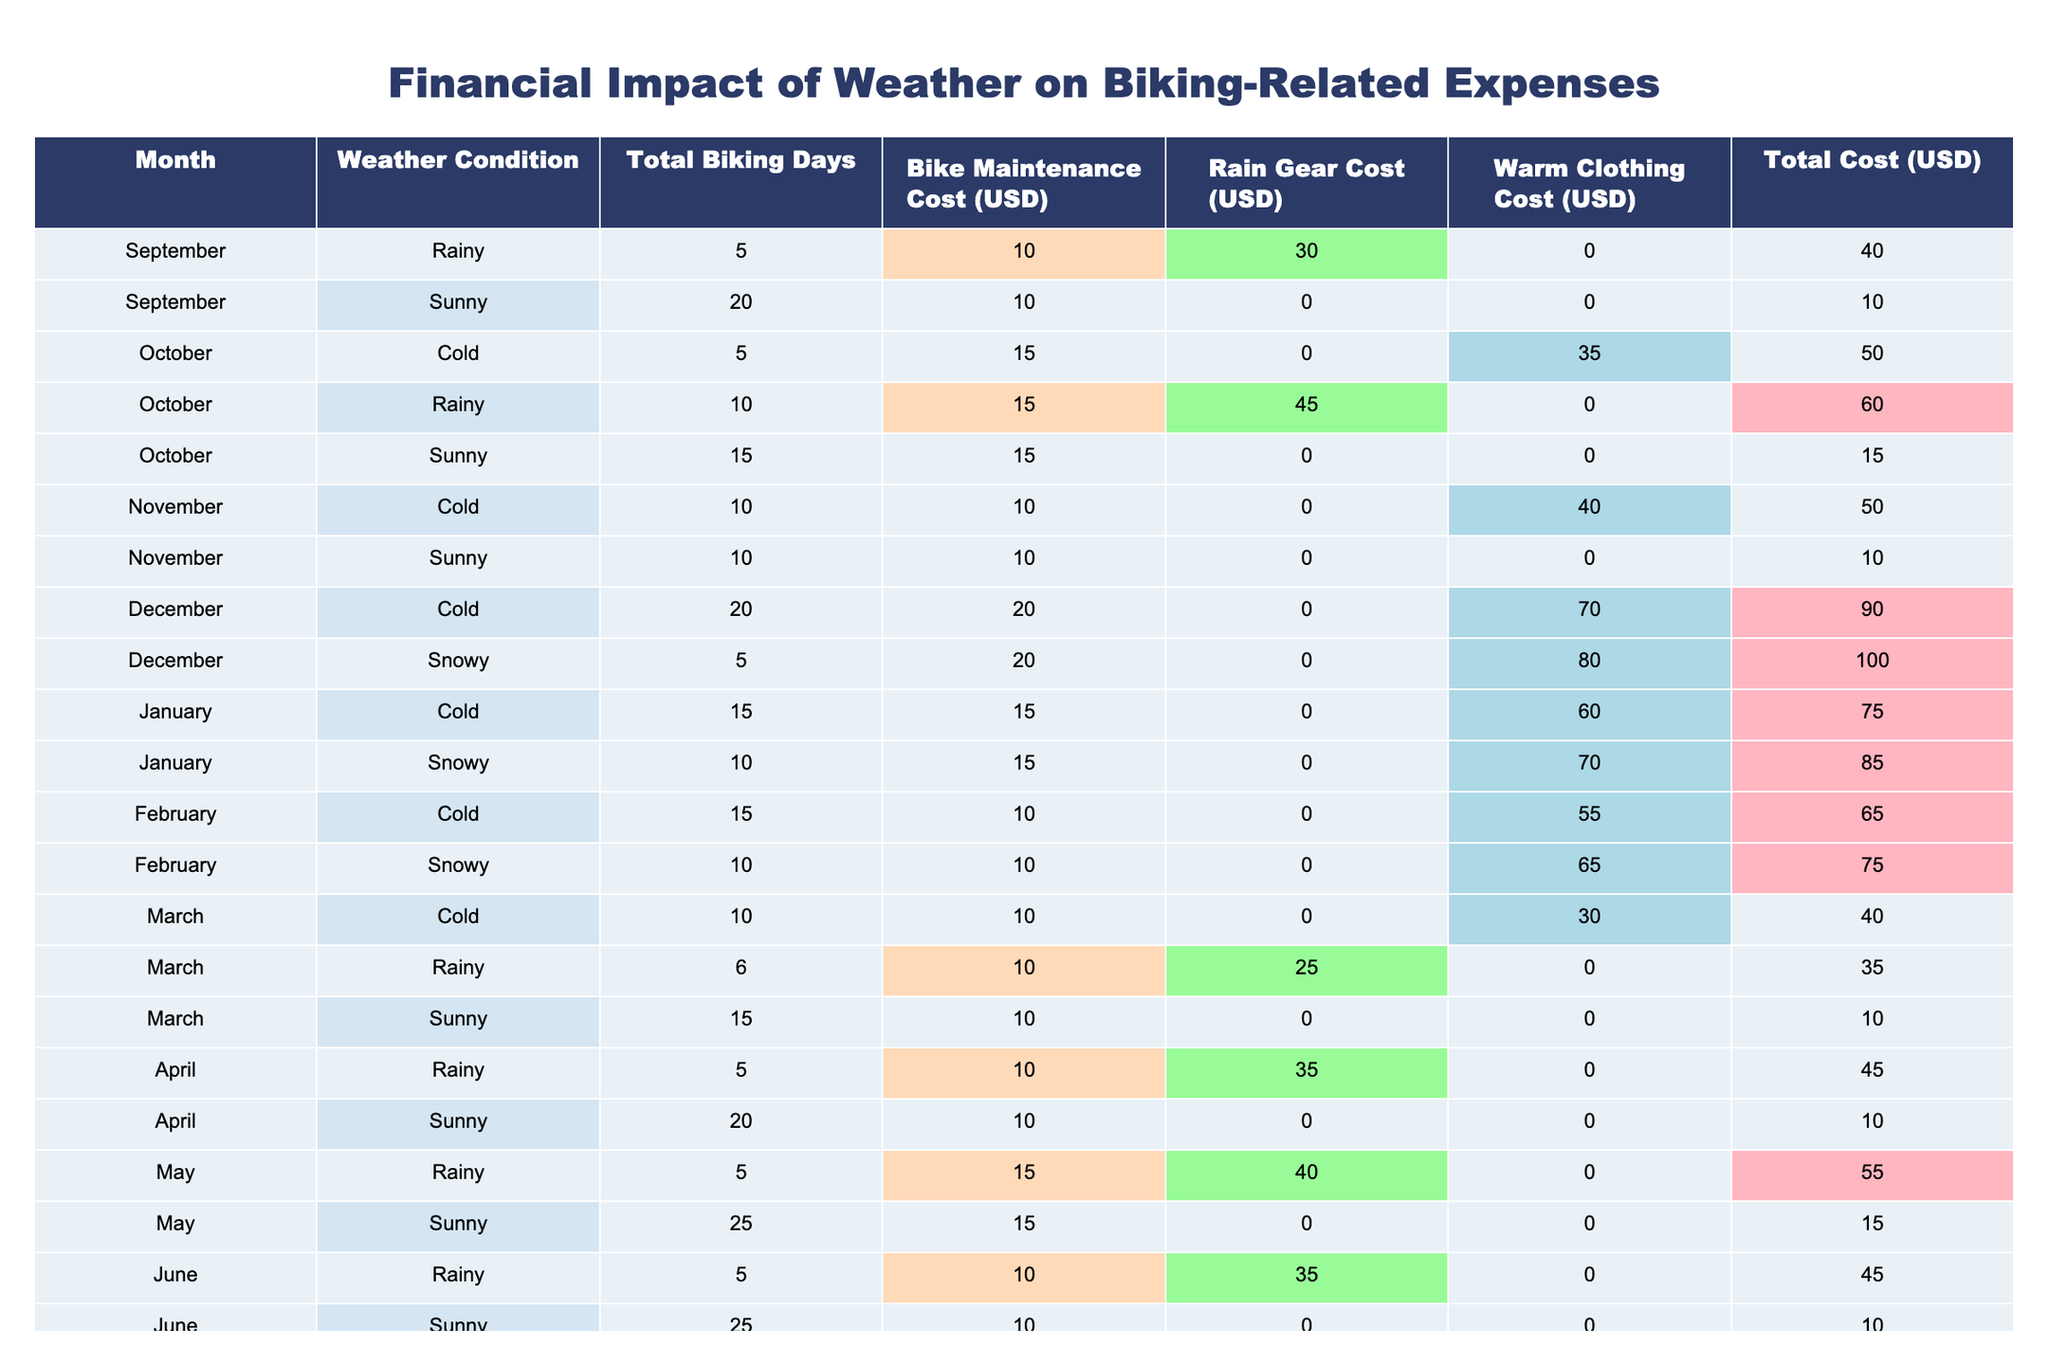What is the total biking cost in December? In December, there are two weather conditions: Cold and Snowy. The total costs are $90 and $100 respectively. Adding them gives us $90 + $100 = $190.
Answer: 190 Which month has the highest total cost of biking? Looking at the table, December has the highest total costs of $90 (Cold) and $100 (Snowy), totaling $190. No other month exceeds this total, making December the month with the highest costs.
Answer: December What percentage of total biking days in October were rainy? In October, the total biking days are 15 (Sunny) + 10 (Rainy) + 5 (Cold) = 30. The rainy biking days are 10, so the percentage is (10/30) * 100 = 33.33%.
Answer: 33.33% Is it true that biking costs decrease during sunny weather? By analyzing the costs when the weather is sunny, the costs recorded are $10 in September, $15 in October, $10 in November, $10 in April, $15 in May, and $10 in June. Since all these values are below $20, we can conclude that this statement is true.
Answer: True Calculate the average maintenance cost for all months. To find the average maintenance cost, sum all the maintenance costs: 10 + 10 + 15 + 15 + 15 + 10 + 20 + 20 + 15 + 10 + 10 + 10 + 10 + 15 + 10 + 10 = 230. There are 16 months of data, so the average is 230 / 16 = 14.375.
Answer: 14.375 What is the total cost of biking on rainy days throughout the academic year? For the rainy days: September $40, October $60, November $45, March $35, April $45, and May $55. Adding these gives $40 + $60 + $45 + $35 + $45 + $55 = $280.
Answer: 280 Which month has the lowest total biking cost? By examining the total costs per month, September has the lowest costs: $10 (Sunny) and $40 (Rainy), totaling $50. No other month has a total lower than this.
Answer: September What is the difference between the total costs in June (Sunny and Rainy) and January (Cold and Snowy)? In June, the total costs are $10 (Sunny) and $45 (Rainy), giving total June costs of $55. In January, costs are $75 (Cold) and $85 (Snowy), totaling $160. The difference is $160 - $55 = $105.
Answer: 105 